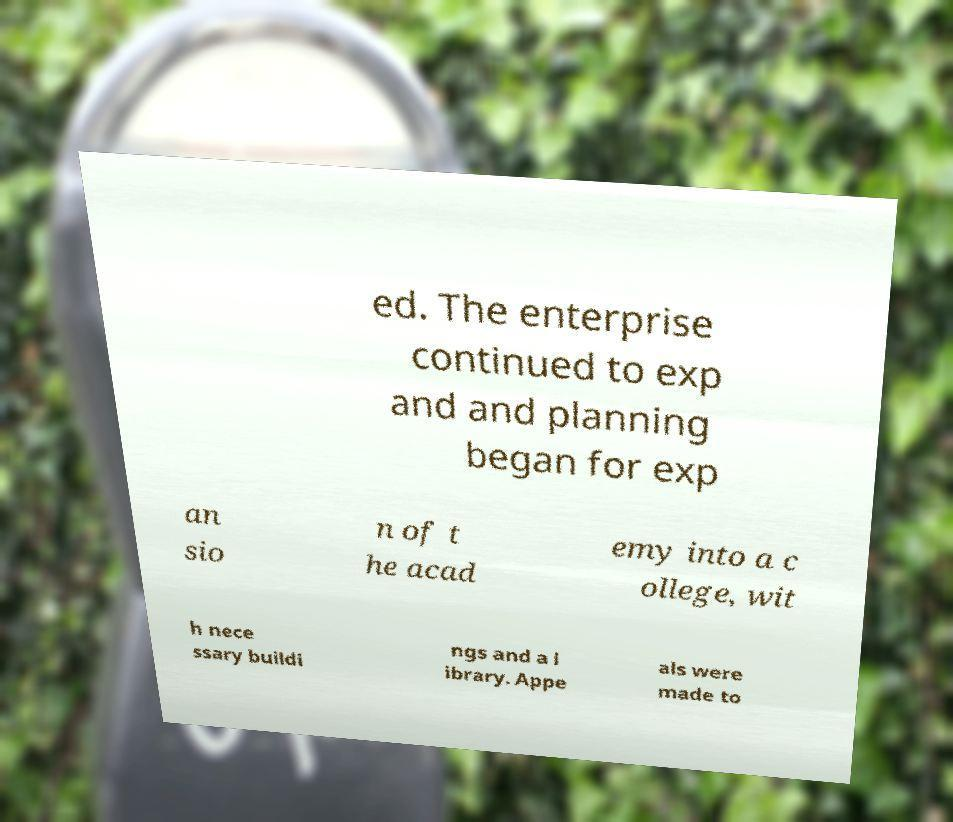Can you accurately transcribe the text from the provided image for me? ed. The enterprise continued to exp and and planning began for exp an sio n of t he acad emy into a c ollege, wit h nece ssary buildi ngs and a l ibrary. Appe als were made to 